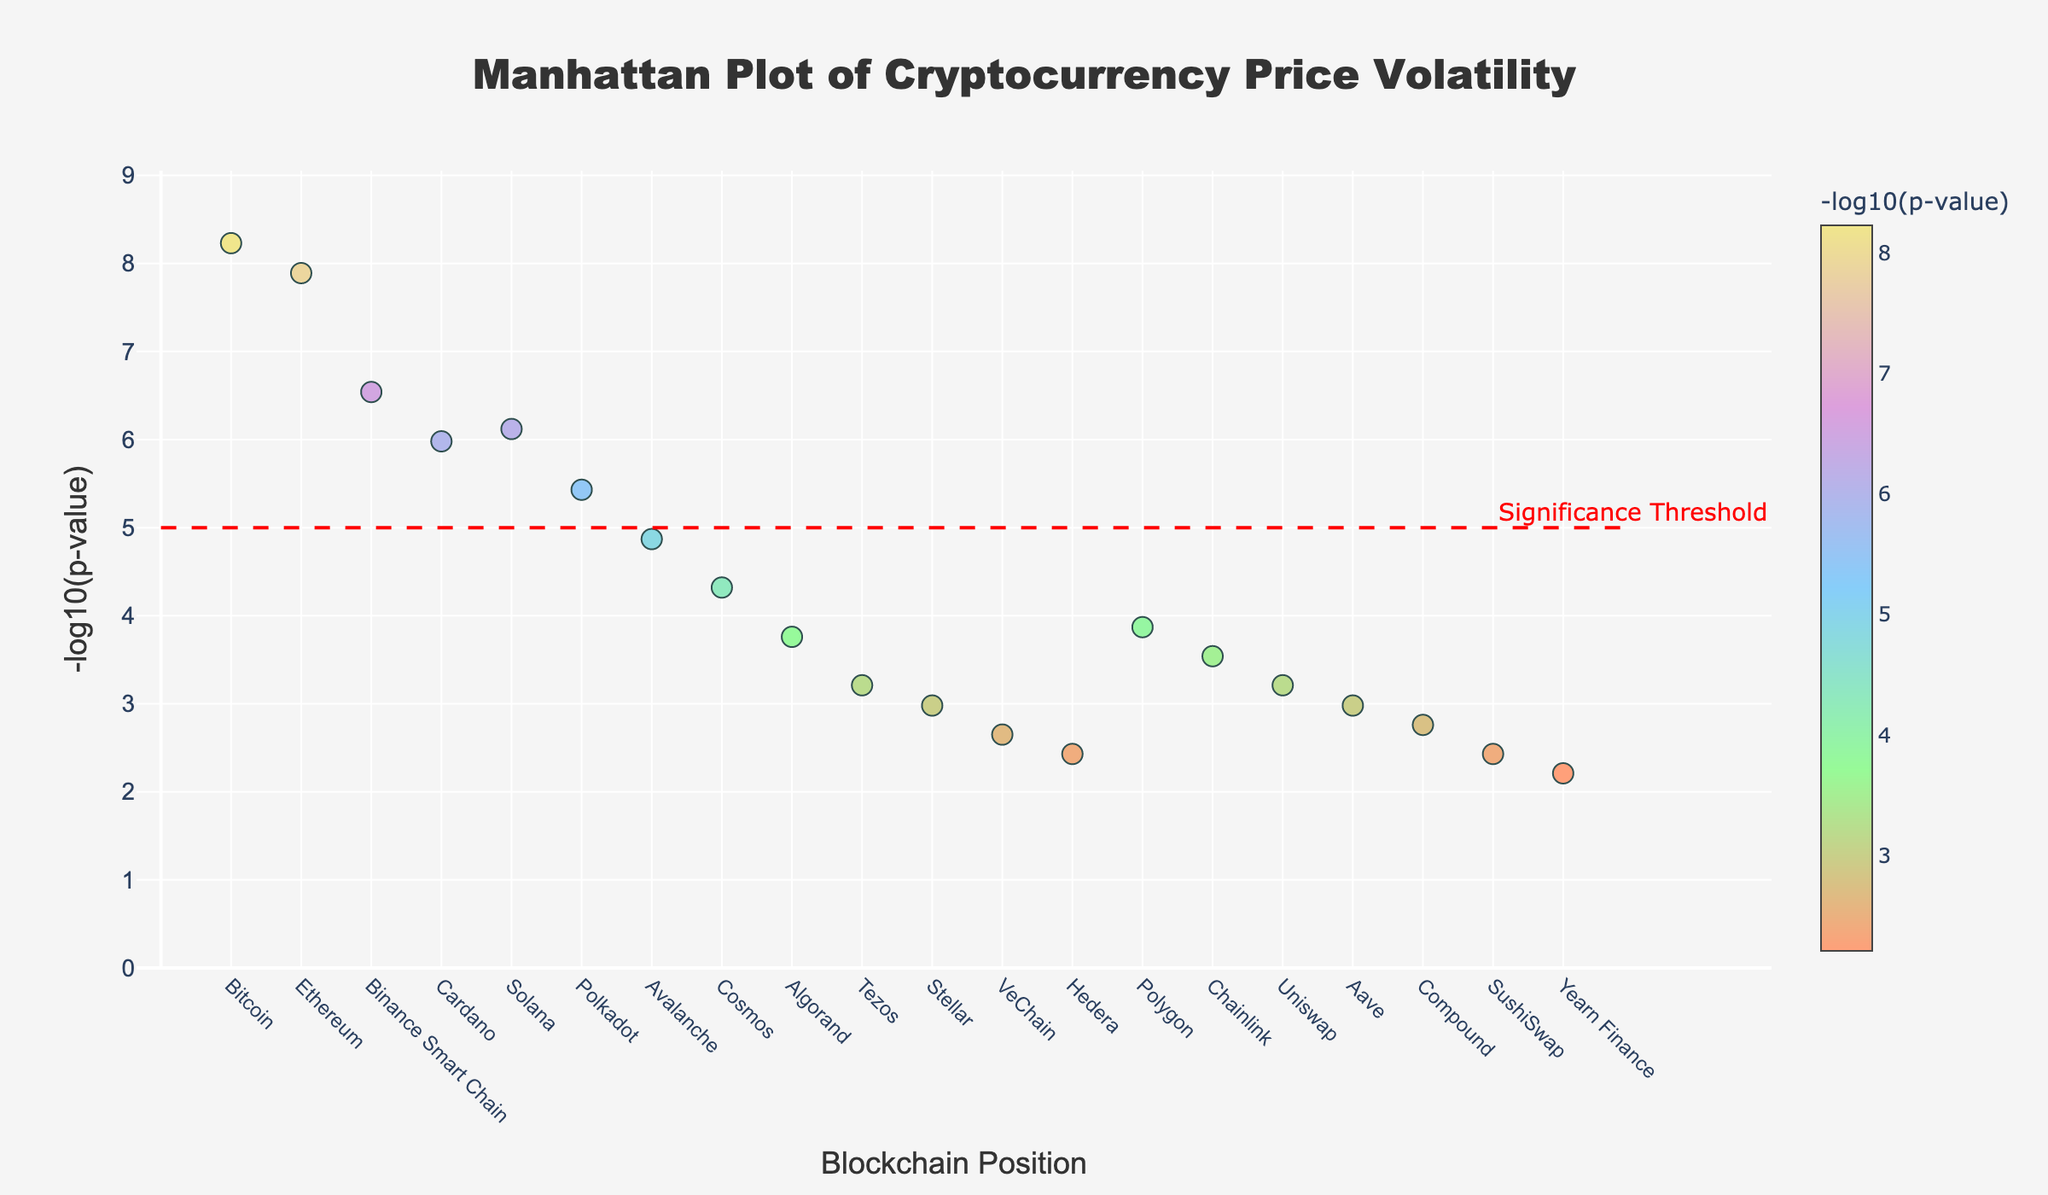what is the title of the plot? The title of the plot is shown at the top of the figure. It indicates the subject or focus of the visualization.
Answer: Manhattan Plot of Cryptocurrency Price Volatility Which blockchain network has the highest -log10(p-value)? The -log10(p-value) for each blockchain network is represented on the y-axis. The highest value can be identified by looking for the topmost point on the plot.
Answer: Bitcoin How many blockchain networks have a -log10(p-value) above the significance threshold? The significance threshold line is drawn at y=5. Count the number of data points that are above this line.
Answer: 5 What color represents the -log10(p-value) for Ethereum? Each -log10(p-value) point is colored based on its value. Use the color bar legend to determine the color that corresponds to Ethereum's -log10(p-value).
Answer: A hue close to dark green Which blockchain networks have a -log10(p-value) below 3? Identify the data points that fall below the y=3 line and refer to the x-axis labels or hover text for network names.
Answer: VeChain, Hedera, SushiSwap, Yearn Finance What is the position on the x-axis for Cardano? Each blockchain's position is labeled on the x-axis. Locate the block labeled with “Cardano” to find its position.
Answer: 4 Compare the -log10(p-value) between Solana and Polkadot. Which is higher? Look at the y-values for Solana and Polkadot and compare their -log10(p-values) directly from the plot.
Answer: Solana What is the average -log10(p-value) of the first three blockchain networks? The first three blockchain networks are Bitcoin, Ethereum, and Binance Smart Chain. Calculate the average of their -log10(p-values): (8.23 + 7.89 + 6.54) / 3.
Answer: 7.55 How does the -log10(p-value) of Polygon compare to that of Algorand? Locate both Polygon and Algorand on the plot. Compare their heights (y-values) to see which is higher.
Answer: Higher Is there any blockchain network with a -log10(p-value) exactly at the significance threshold? Find the significance threshold line at y=5 and check if any data point lies exactly on this line.
Answer: No 